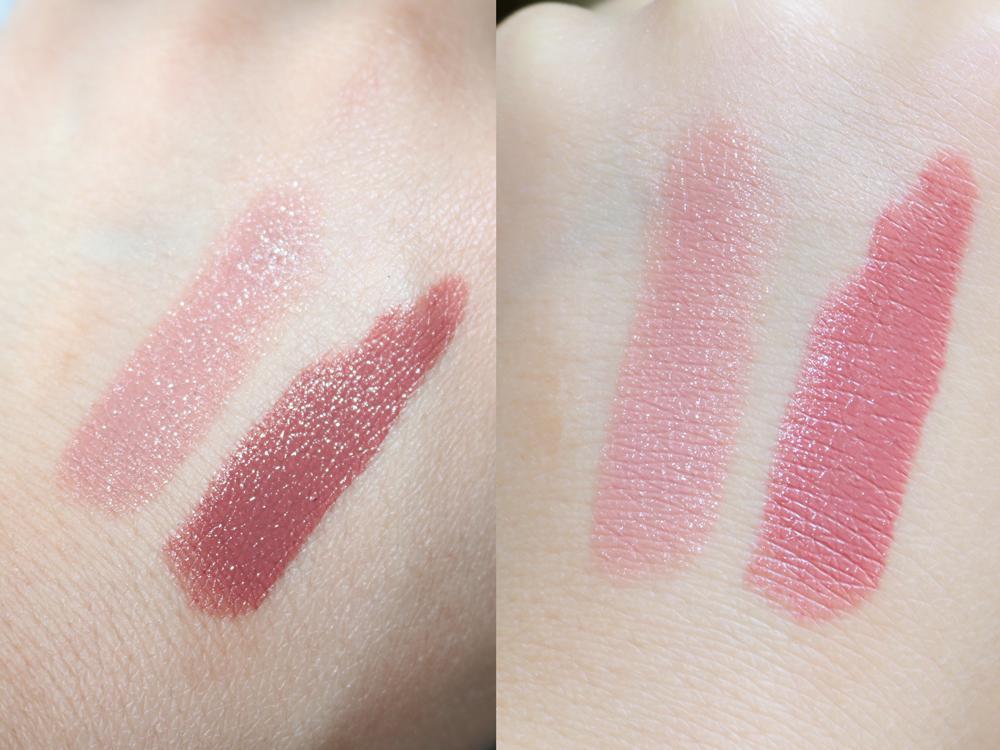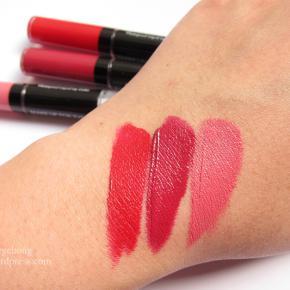The first image is the image on the left, the second image is the image on the right. Evaluate the accuracy of this statement regarding the images: "Each image shows an arm comparing the shades of at least two lipstick colors.". Is it true? Answer yes or no. Yes. The first image is the image on the left, the second image is the image on the right. Considering the images on both sides, is "The left image shows skin with two lipstick stripes on it, and the right image shows the top of a hand with three lipstick stripes." valid? Answer yes or no. Yes. 